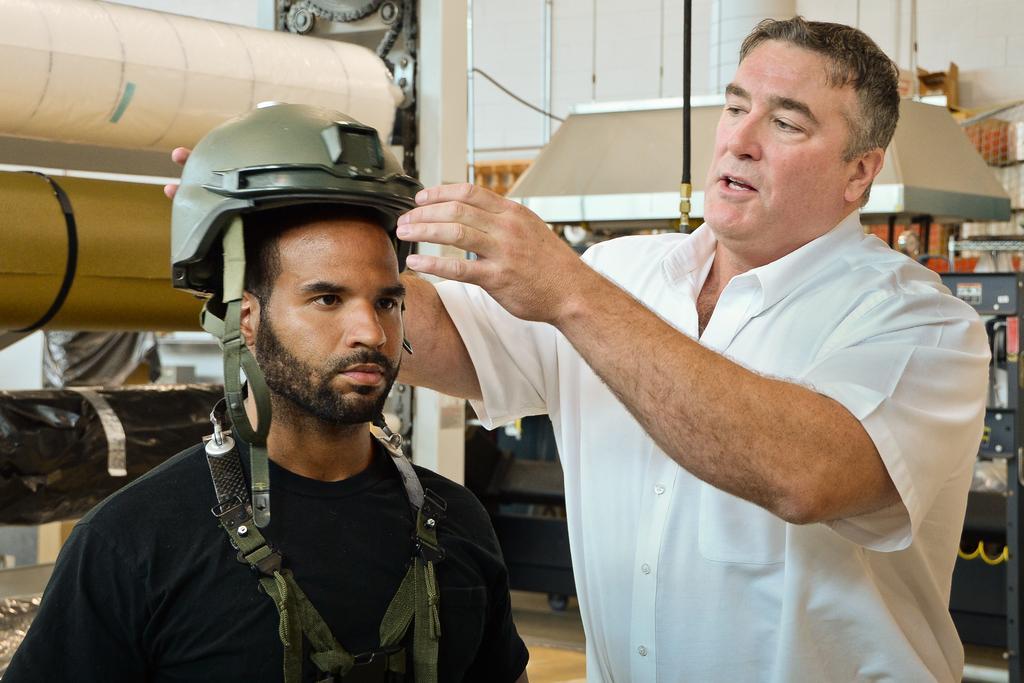Could you give a brief overview of what you see in this image? In this image in the front there are persons. On the left side there is a person wearing a green colour helmet. In the background there are objects which are black and white in colour and there is a wall and there is a chain. 